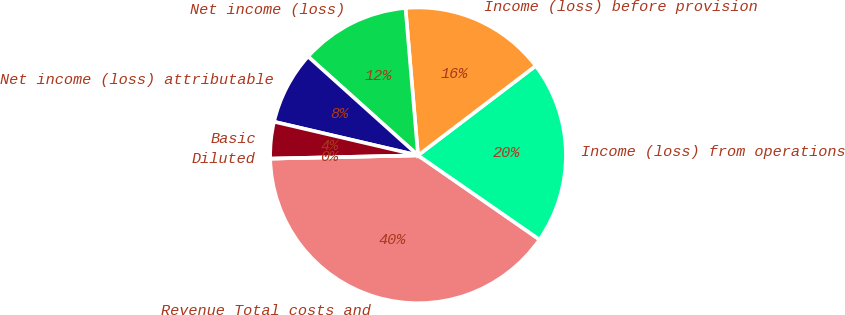Convert chart to OTSL. <chart><loc_0><loc_0><loc_500><loc_500><pie_chart><fcel>Revenue Total costs and<fcel>Income (loss) from operations<fcel>Income (loss) before provision<fcel>Net income (loss)<fcel>Net income (loss) attributable<fcel>Basic<fcel>Diluted<nl><fcel>40.0%<fcel>20.0%<fcel>16.0%<fcel>12.0%<fcel>8.0%<fcel>4.0%<fcel>0.0%<nl></chart> 